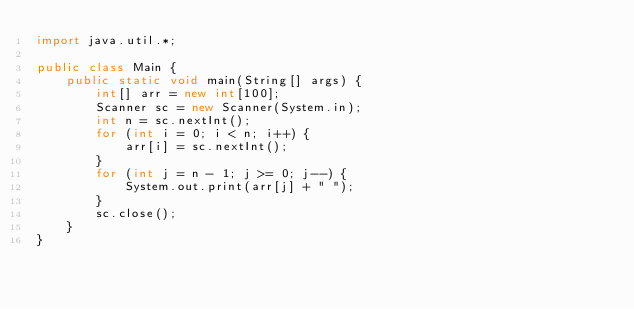<code> <loc_0><loc_0><loc_500><loc_500><_Java_>import java.util.*;

public class Main {
    public static void main(String[] args) {
        int[] arr = new int[100];
        Scanner sc = new Scanner(System.in);
        int n = sc.nextInt();
        for (int i = 0; i < n; i++) {
            arr[i] = sc.nextInt();
        }
        for (int j = n - 1; j >= 0; j--) {
            System.out.print(arr[j] + " ");
        }
        sc.close();
    }
}
</code> 